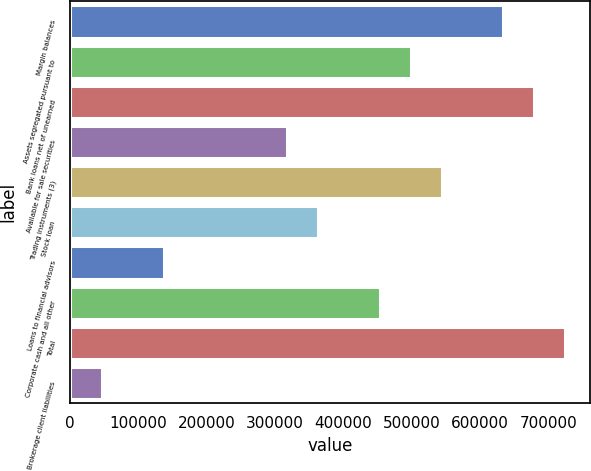Convert chart. <chart><loc_0><loc_0><loc_500><loc_500><bar_chart><fcel>Margin balances<fcel>Assets segregated pursuant to<fcel>Bank loans net of unearned<fcel>Available for sale securities<fcel>Trading instruments (3)<fcel>Stock loan<fcel>Loans to financial advisors<fcel>Corporate cash and all other<fcel>Total<fcel>Brokerage client liabilities<nl><fcel>633771<fcel>498386<fcel>678899<fcel>317873<fcel>543514<fcel>363002<fcel>137361<fcel>453258<fcel>724027<fcel>47104.2<nl></chart> 